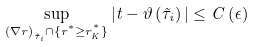<formula> <loc_0><loc_0><loc_500><loc_500>\sup _ { \left ( \nabla r \right ) _ { \tilde { \tau } _ { i } } \cap \{ r ^ { ^ { * } } \geq r ^ { ^ { * } } _ { K } \} } | t - \vartheta \left ( \tilde { \tau } _ { i } \right ) | \leq C \left ( \epsilon \right )</formula> 